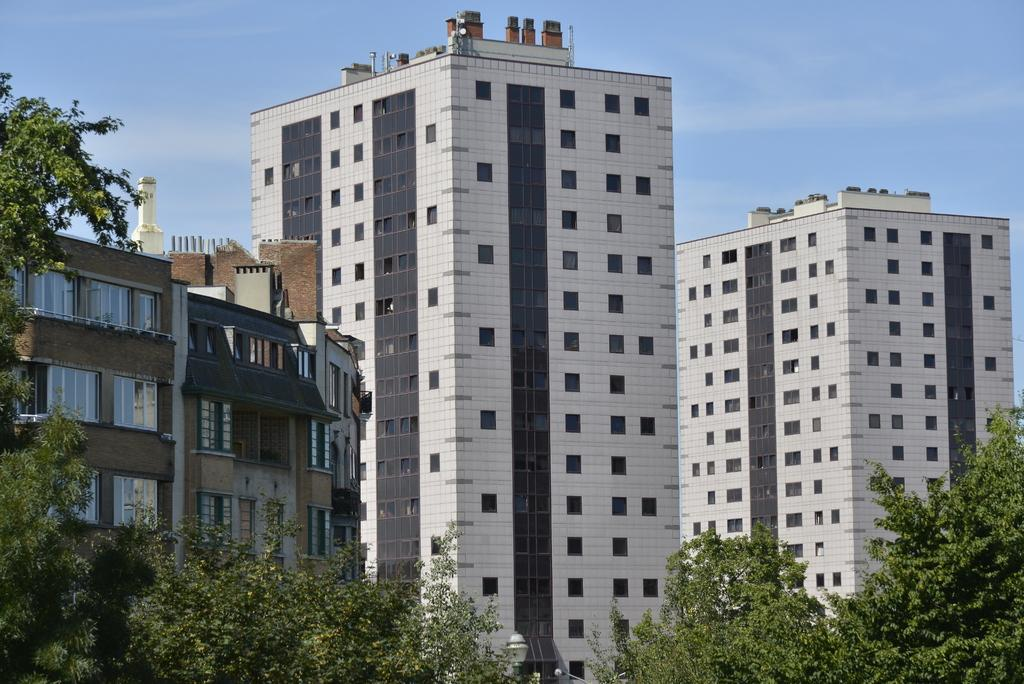What type of vegetation can be seen in the image? There are trees in the image. What structures are present in the image that provide light? There are light poles in the image. What architectural features can be seen on the buildings in the image? The buildings in the image have windows. What is visible in the background of the image? The sky is visible in the background of the image. Where is the tray located in the image? There is no tray present in the image. What type of truck can be seen driving through the image? There is no truck visible in the image. 